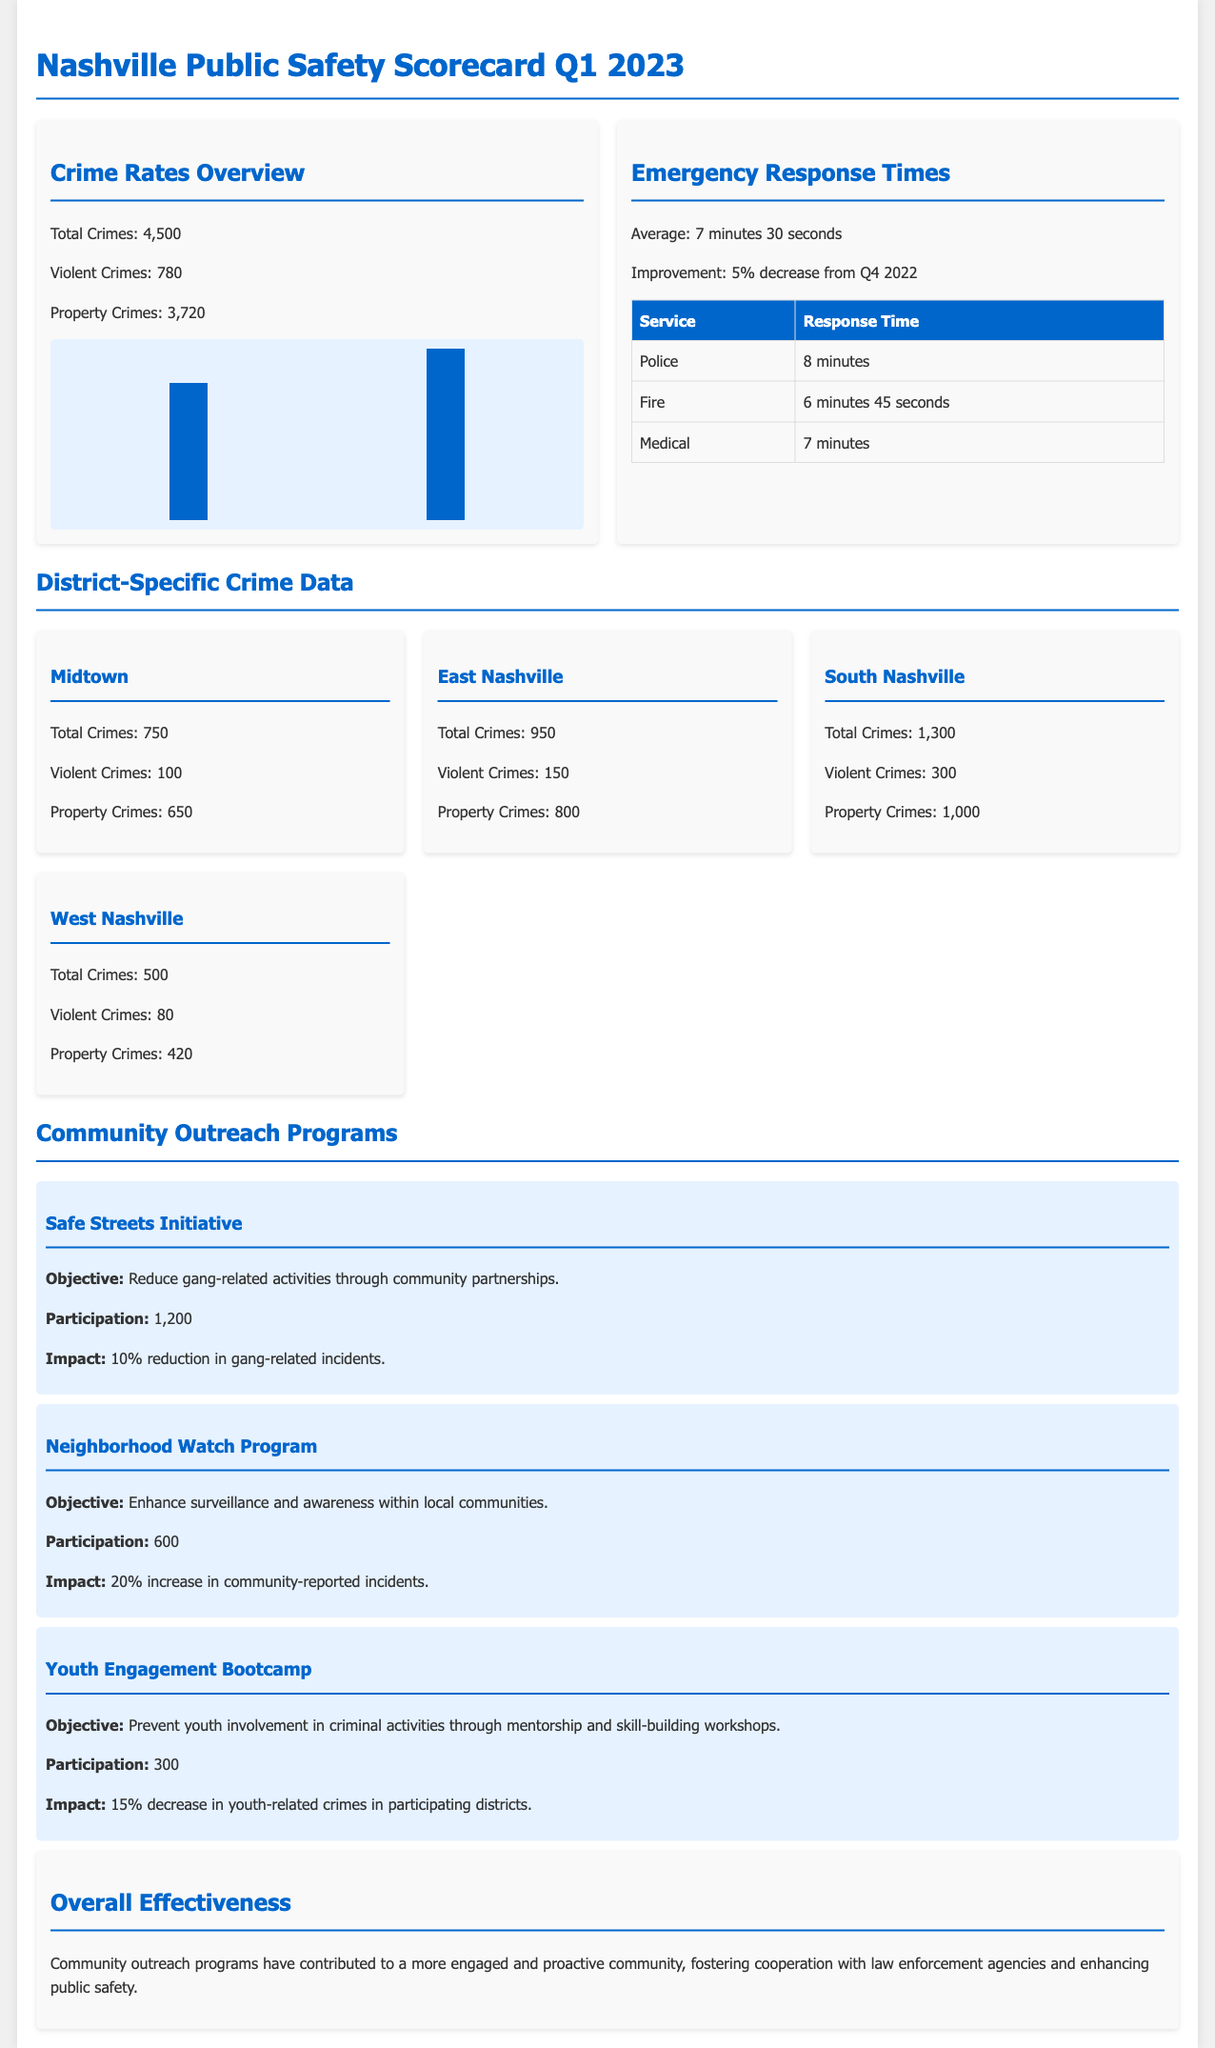What is the total number of crimes reported? The total number of crimes is listed as 4,500 in the document.
Answer: 4,500 What percentage decrease in emergency response times was achieved? The document states there was a 5% decrease in response times from Q4 2022.
Answer: 5% What is the average emergency response time? The document specifies the average emergency response time as 7 minutes 30 seconds.
Answer: 7 minutes 30 seconds How many violent crimes were reported in South Nashville? The document indicates that South Nashville had 300 violent crimes.
Answer: 300 What impact did the Neighborhood Watch Program have on community-reported incidents? The document notes a 20% increase in community-reported incidents due to the program.
Answer: 20% increase What was the objective of the Safe Streets Initiative? The document states the objective was to reduce gang-related activities.
Answer: Reduce gang-related activities How many participants were in the Youth Engagement Bootcamp? The document lists 300 participants in the Youth Engagement Bootcamp.
Answer: 300 What is the total number of property crimes in East Nashville? The document declares there were 800 property crimes in East Nashville.
Answer: 800 What is the overall effectiveness of the community outreach programs according to the document? The document emphasizes that the programs contributed to a more engaged and proactive community.
Answer: More engaged and proactive community 